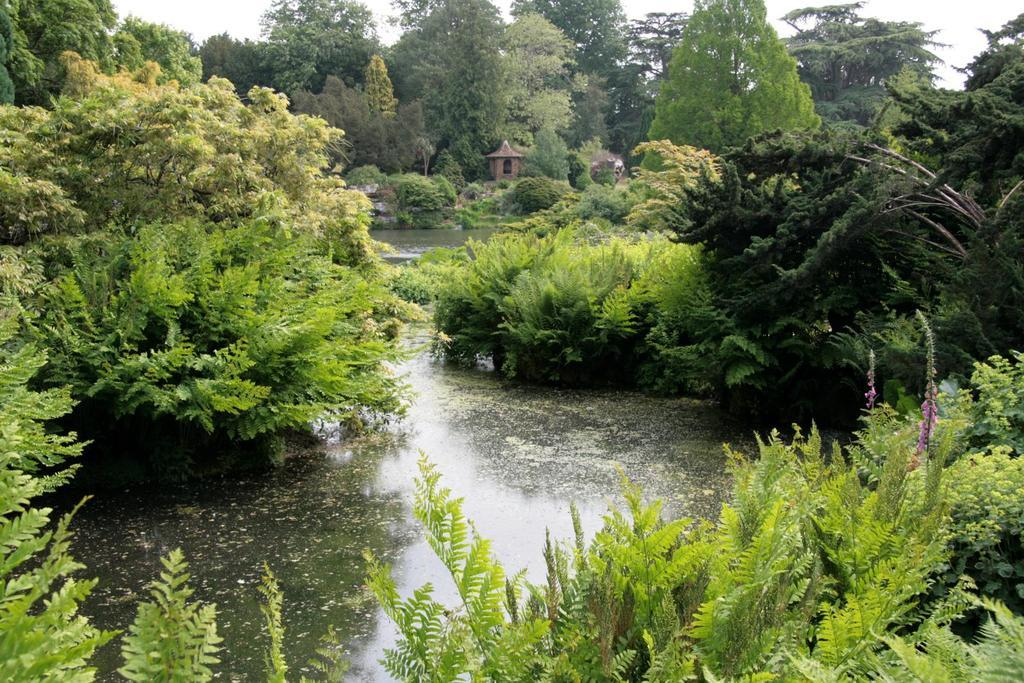What is visible in the image? Water is visible in the image. What can be seen in the background of the image? There are bushes, objects, and trees in the background of the image. What is the topic of the discussion taking place at the table in the image? There is no table or discussion present in the image. 